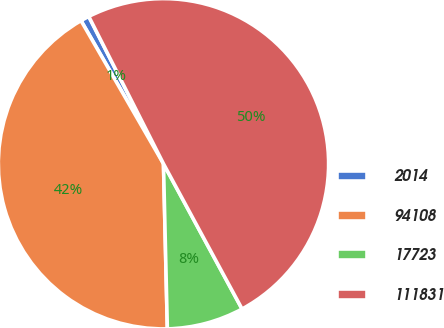Convert chart. <chart><loc_0><loc_0><loc_500><loc_500><pie_chart><fcel>2014<fcel>94108<fcel>17723<fcel>111831<nl><fcel>0.85%<fcel>42.05%<fcel>7.52%<fcel>49.57%<nl></chart> 